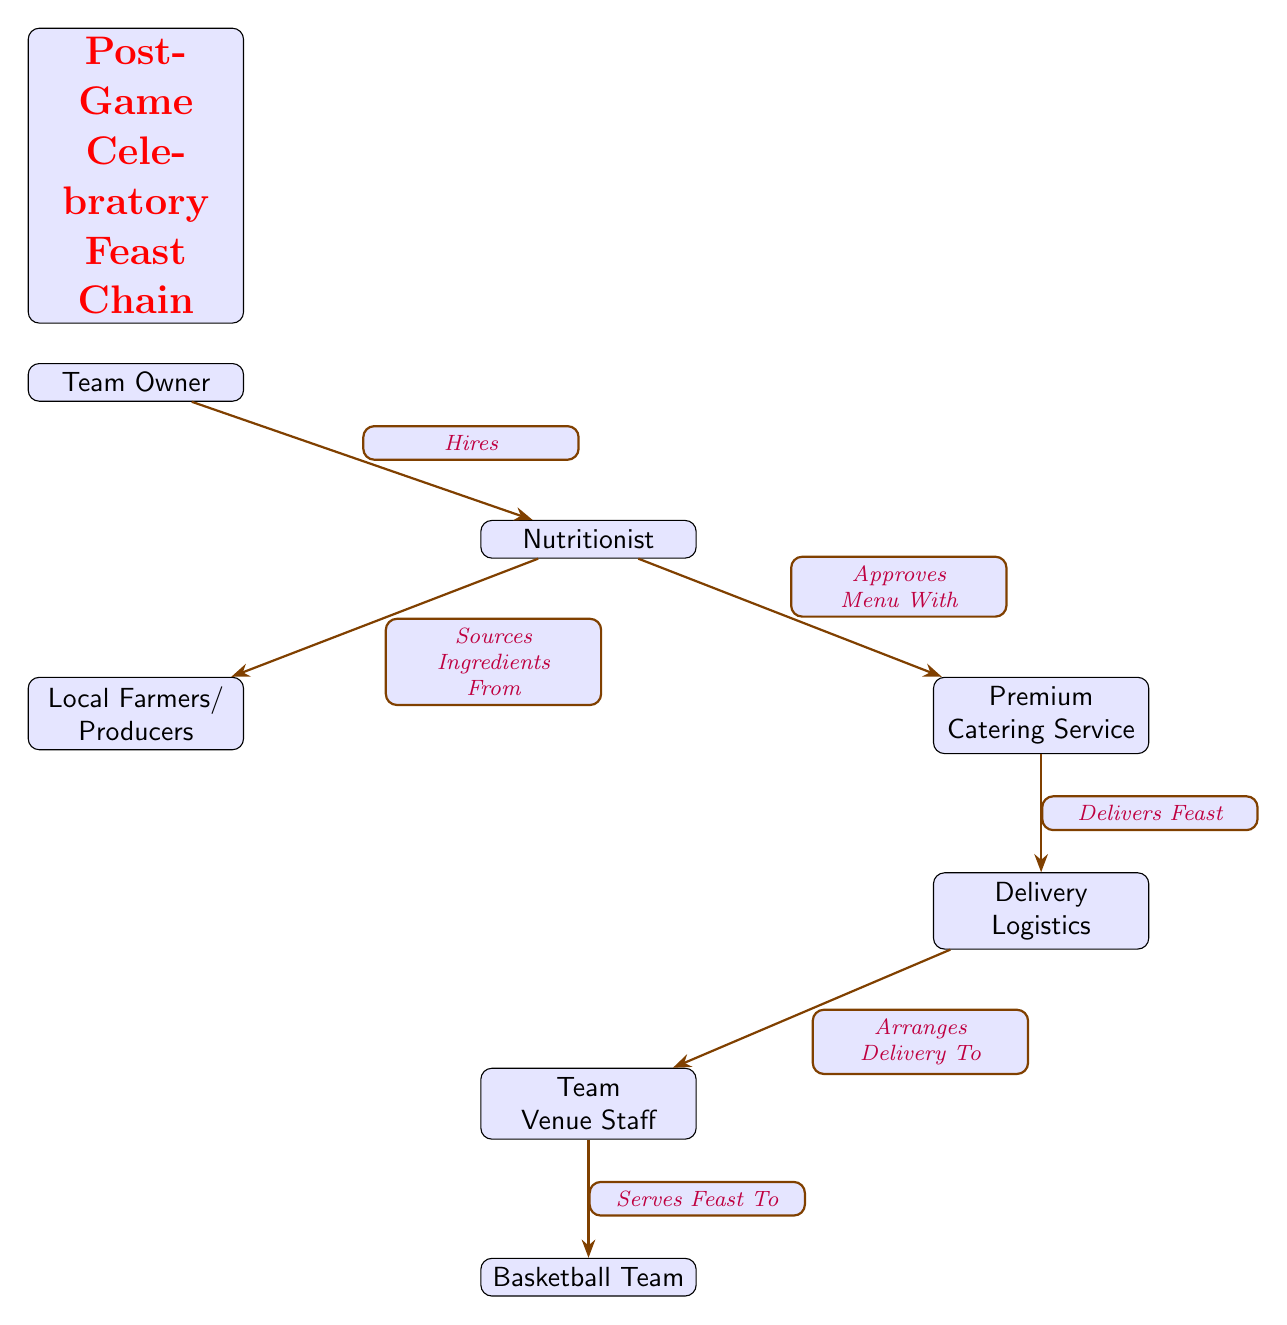What is the starting point of the food chain? The food chain begins with the "Team Owner" who initiates the process by hiring a nutritionist.
Answer: Team Owner Who sources ingredients from local producers? The "Nutritionist" is responsible for sourcing ingredients from local farmers and producers.
Answer: Nutritionist How many edges are in the food chain? By counting all the connections between nodes in the diagram, there are a total of six edges representing the flow of the celebratory feast process.
Answer: 6 Who approves the menu with the catering service? The "Nutritionist" collaborates with the "Premium Catering Service" to approve the menu for the feast.
Answer: Nutritionist What is the final step in the food chain? The final step occurs when the "Team Venue Staff" serves the feast to the "Basketball Team".
Answer: Serves Feast To What is the role of Delivery Logistics in the food chain? "Delivery Logistics" handles the delivery of the feast from the catering service to the team venue staff, ensuring that everything arrives on time.
Answer: Arranges Delivery To Which parties are directly involved in the sourcing process? The "Nutritionist" sources ingredients directly from "Local Farmers/Producers". These are the two parties engaged in the sourcing aspect of the diagram.
Answer: Nutritionist, Local Farmers/Producers How does the feasting process begin after a game? After a game, the process begins when the "Team Owner" hires a nutritionist who then orchestrates the sourcing and delivery of the food.
Answer: Hires Which node has the responsibility for the delivery logistics? The node responsible for logistics of the feast delivery is "Delivery Logistics".
Answer: Delivery Logistics 